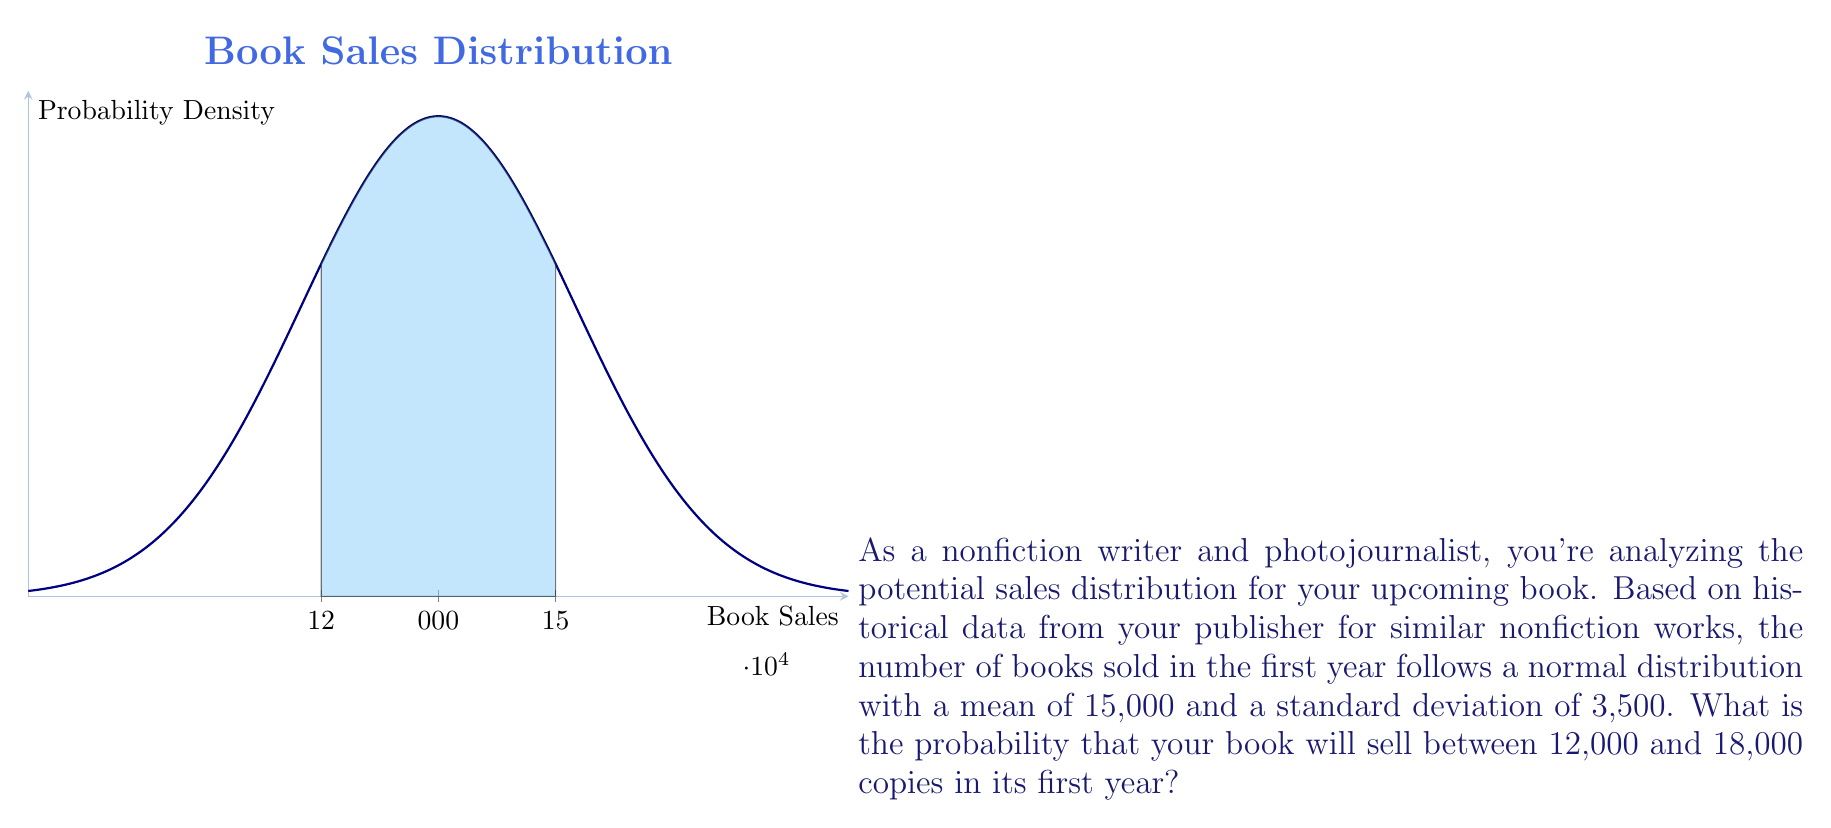Give your solution to this math problem. To solve this problem, we'll use the properties of the normal distribution and the concept of z-scores. Let's break it down step-by-step:

1) We're given that the book sales follow a normal distribution with:
   Mean (μ) = 15,000
   Standard deviation (σ) = 3,500

2) We want to find P(12,000 ≤ X ≤ 18,000), where X is the number of books sold.

3) To use the standard normal distribution table, we need to convert these values to z-scores:

   For 12,000: $z_1 = \frac{12000 - 15000}{3500} = -0.8571$
   For 18,000: $z_2 = \frac{18000 - 15000}{3500} = 0.8571$

4) Now, we need to find P(-0.8571 ≤ Z ≤ 0.8571), where Z is the standard normal variable.

5) Using the standard normal distribution table or a calculator:
   P(Z ≤ 0.8571) = 0.8043
   P(Z ≤ -0.8571) = 1 - 0.8043 = 0.1957

6) The probability we're looking for is:
   P(-0.8571 ≤ Z ≤ 0.8571) = P(Z ≤ 0.8571) - P(Z ≤ -0.8571)
                            = 0.8043 - 0.1957
                            = 0.6086

7) Therefore, the probability that your book will sell between 12,000 and 18,000 copies in its first year is approximately 0.6086 or 60.86%.
Answer: 0.6086 or 60.86% 